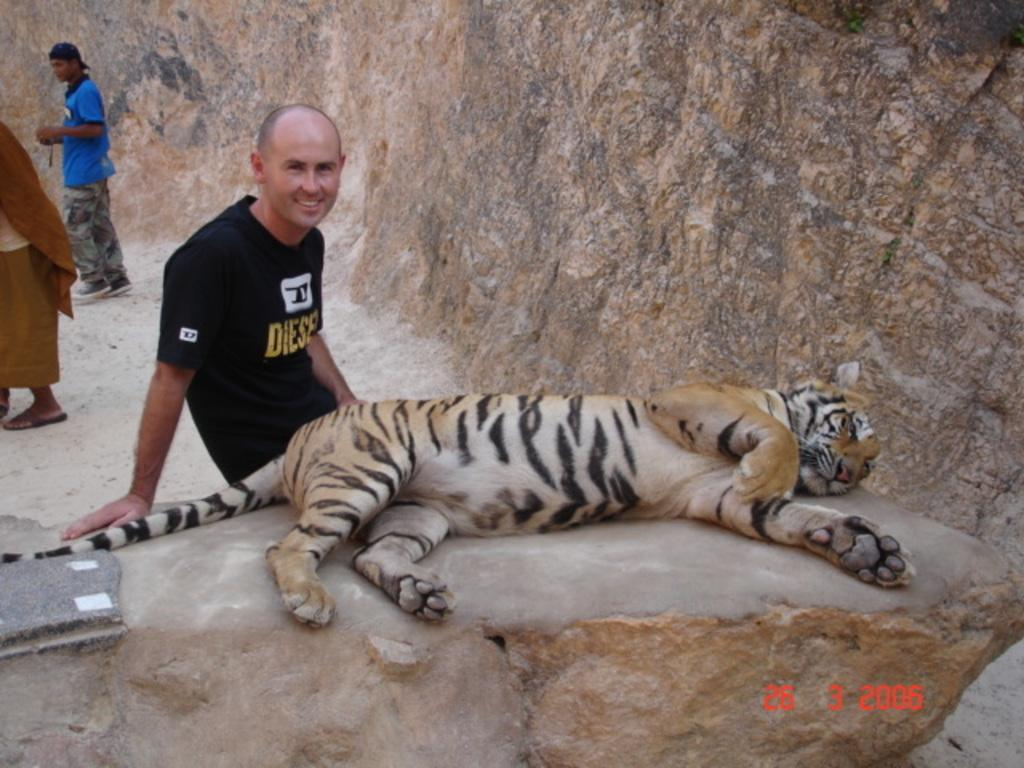What animal is laying on the ground in the image? There is a tiger laying on the ground in the image. Who is beside the tiger in the image? There is a man beside the tiger in the image. How many people are visible behind the man in the image? There are two people behind the man in the image. What type of gold wire is being used to support the tiger's elbow in the image? There is no gold wire or mention of an elbow in the image; the tiger is laying on the ground, and the man is beside it. 